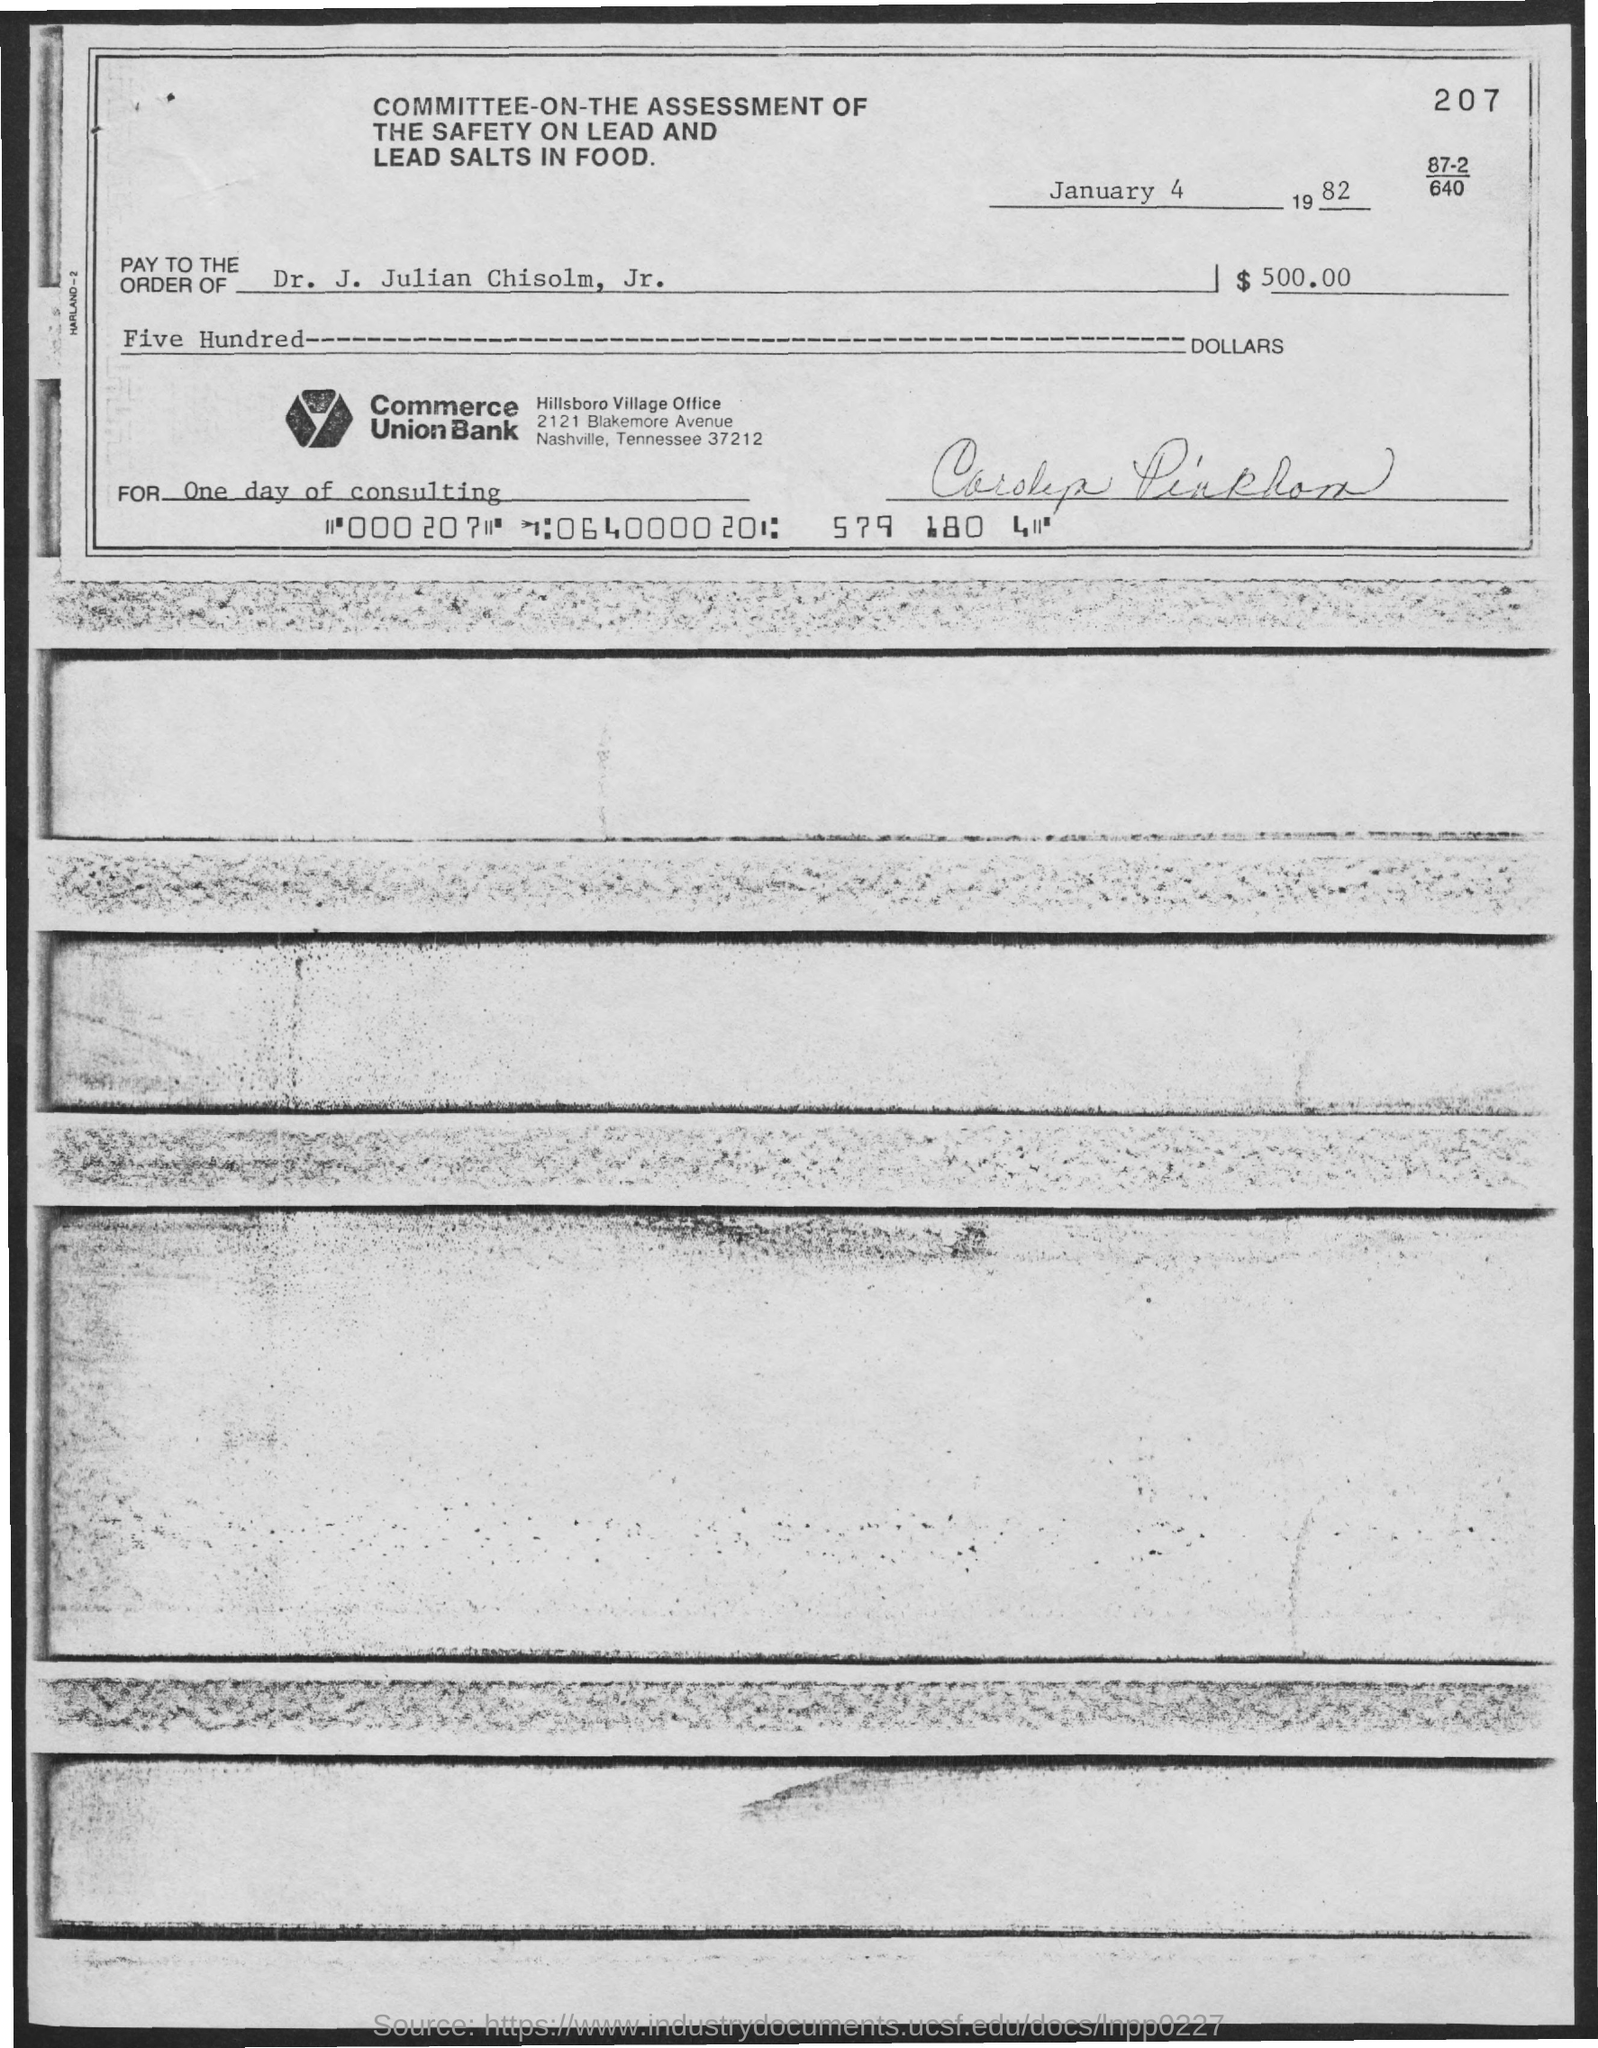Give some essential details in this illustration. On January 4th, 1982, the date is. The amount is five hundred dollars. The payment is made to Dr. J. Julian Chisolm, Jr. Commerce union bank is the name of the bank. 